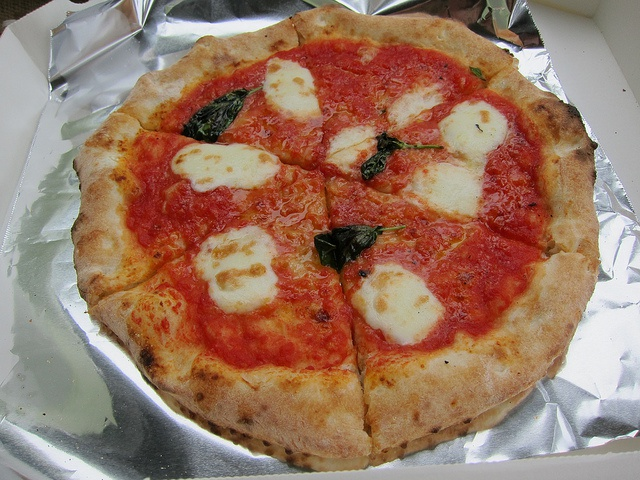Describe the objects in this image and their specific colors. I can see a pizza in black, brown, tan, and gray tones in this image. 